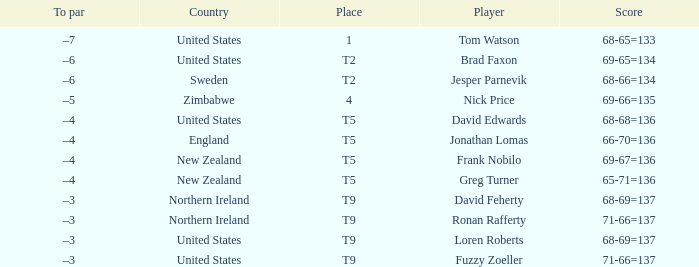Who is the golfer that golfs for Northern Ireland? David Feherty, Ronan Rafferty. 